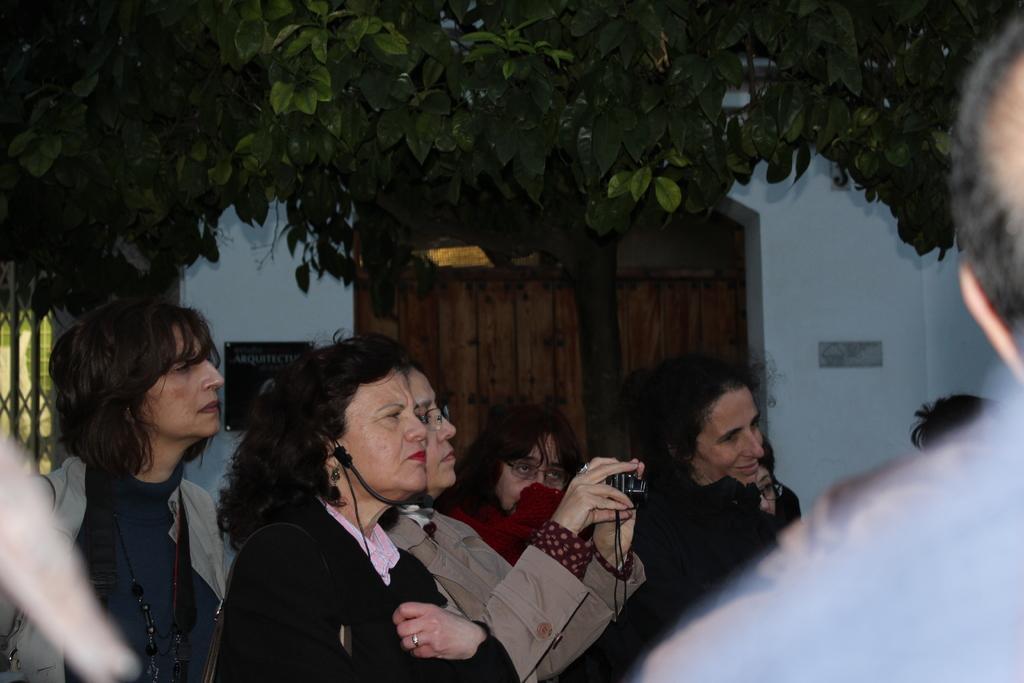Could you give a brief overview of what you see in this image? In the picture we can see a group of people standing and one person is holding a camera and capturing something and in the background, we can see a wall with a door made up of wood and a tree with leaves. 